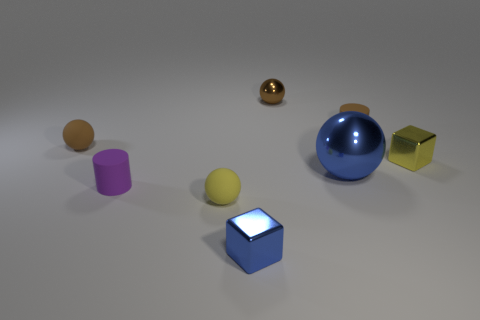Subtract all green cubes. How many brown balls are left? 2 Subtract all yellow matte balls. How many balls are left? 3 Subtract all blue spheres. How many spheres are left? 3 Add 1 tiny objects. How many objects exist? 9 Subtract all cylinders. How many objects are left? 6 Subtract all red spheres. Subtract all gray blocks. How many spheres are left? 4 Subtract 0 yellow cylinders. How many objects are left? 8 Subtract all tiny cyan matte cylinders. Subtract all cylinders. How many objects are left? 6 Add 5 tiny metal blocks. How many tiny metal blocks are left? 7 Add 6 big blue metallic objects. How many big blue metallic objects exist? 7 